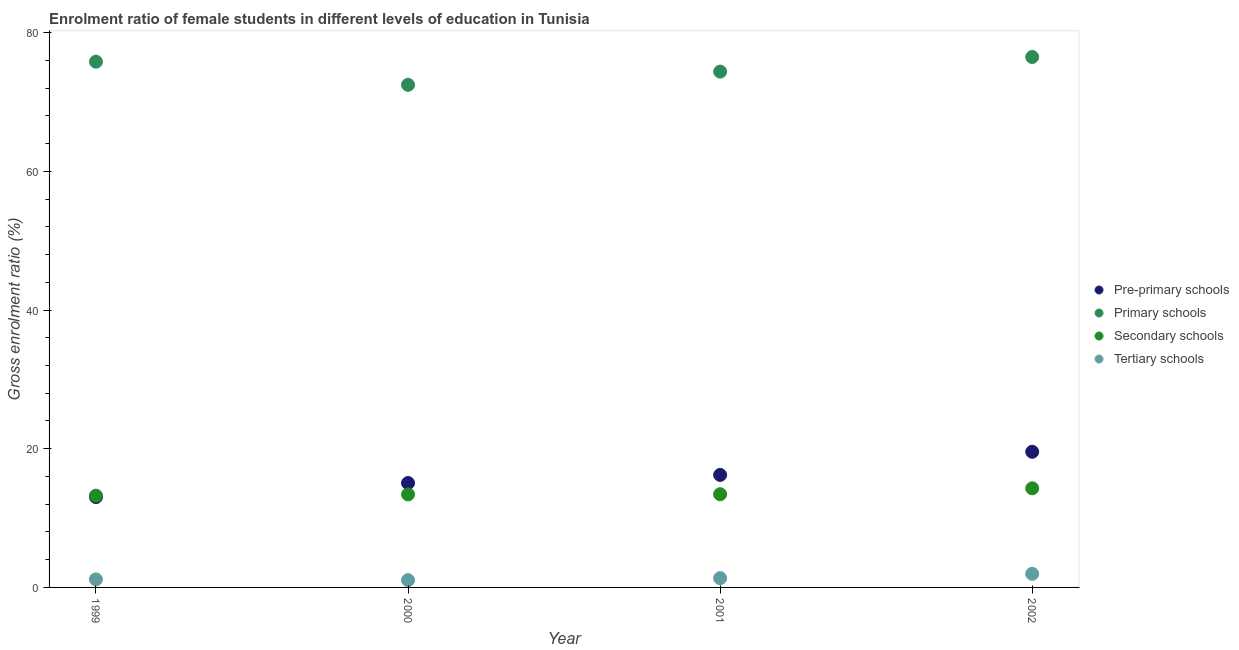What is the gross enrolment ratio(male) in primary schools in 2002?
Make the answer very short. 76.49. Across all years, what is the maximum gross enrolment ratio(male) in tertiary schools?
Keep it short and to the point. 1.96. Across all years, what is the minimum gross enrolment ratio(male) in primary schools?
Offer a terse response. 72.48. In which year was the gross enrolment ratio(male) in primary schools maximum?
Make the answer very short. 2002. What is the total gross enrolment ratio(male) in tertiary schools in the graph?
Provide a short and direct response. 5.51. What is the difference between the gross enrolment ratio(male) in primary schools in 1999 and that in 2001?
Your response must be concise. 1.43. What is the difference between the gross enrolment ratio(male) in secondary schools in 2001 and the gross enrolment ratio(male) in primary schools in 2002?
Give a very brief answer. -63.05. What is the average gross enrolment ratio(male) in pre-primary schools per year?
Your answer should be very brief. 15.97. In the year 1999, what is the difference between the gross enrolment ratio(male) in primary schools and gross enrolment ratio(male) in pre-primary schools?
Your answer should be compact. 62.79. In how many years, is the gross enrolment ratio(male) in tertiary schools greater than 8 %?
Make the answer very short. 0. What is the ratio of the gross enrolment ratio(male) in tertiary schools in 2000 to that in 2001?
Offer a terse response. 0.78. Is the gross enrolment ratio(male) in pre-primary schools in 1999 less than that in 2002?
Your answer should be very brief. Yes. Is the difference between the gross enrolment ratio(male) in pre-primary schools in 1999 and 2002 greater than the difference between the gross enrolment ratio(male) in primary schools in 1999 and 2002?
Make the answer very short. No. What is the difference between the highest and the second highest gross enrolment ratio(male) in tertiary schools?
Offer a terse response. 0.62. What is the difference between the highest and the lowest gross enrolment ratio(male) in primary schools?
Your answer should be compact. 4.02. In how many years, is the gross enrolment ratio(male) in pre-primary schools greater than the average gross enrolment ratio(male) in pre-primary schools taken over all years?
Your response must be concise. 2. Is it the case that in every year, the sum of the gross enrolment ratio(male) in tertiary schools and gross enrolment ratio(male) in primary schools is greater than the sum of gross enrolment ratio(male) in secondary schools and gross enrolment ratio(male) in pre-primary schools?
Ensure brevity in your answer.  No. Is it the case that in every year, the sum of the gross enrolment ratio(male) in pre-primary schools and gross enrolment ratio(male) in primary schools is greater than the gross enrolment ratio(male) in secondary schools?
Offer a very short reply. Yes. How many years are there in the graph?
Your answer should be compact. 4. Are the values on the major ticks of Y-axis written in scientific E-notation?
Offer a terse response. No. Does the graph contain grids?
Your answer should be very brief. No. Where does the legend appear in the graph?
Your answer should be compact. Center right. How are the legend labels stacked?
Keep it short and to the point. Vertical. What is the title of the graph?
Your response must be concise. Enrolment ratio of female students in different levels of education in Tunisia. What is the Gross enrolment ratio (%) in Pre-primary schools in 1999?
Offer a very short reply. 13.03. What is the Gross enrolment ratio (%) of Primary schools in 1999?
Keep it short and to the point. 75.81. What is the Gross enrolment ratio (%) of Secondary schools in 1999?
Offer a terse response. 13.23. What is the Gross enrolment ratio (%) of Tertiary schools in 1999?
Offer a terse response. 1.16. What is the Gross enrolment ratio (%) of Pre-primary schools in 2000?
Make the answer very short. 15.05. What is the Gross enrolment ratio (%) in Primary schools in 2000?
Give a very brief answer. 72.48. What is the Gross enrolment ratio (%) of Secondary schools in 2000?
Make the answer very short. 13.41. What is the Gross enrolment ratio (%) in Tertiary schools in 2000?
Offer a terse response. 1.05. What is the Gross enrolment ratio (%) of Pre-primary schools in 2001?
Ensure brevity in your answer.  16.22. What is the Gross enrolment ratio (%) of Primary schools in 2001?
Offer a very short reply. 74.38. What is the Gross enrolment ratio (%) of Secondary schools in 2001?
Provide a succinct answer. 13.44. What is the Gross enrolment ratio (%) of Tertiary schools in 2001?
Ensure brevity in your answer.  1.34. What is the Gross enrolment ratio (%) in Pre-primary schools in 2002?
Offer a terse response. 19.56. What is the Gross enrolment ratio (%) of Primary schools in 2002?
Make the answer very short. 76.49. What is the Gross enrolment ratio (%) of Secondary schools in 2002?
Make the answer very short. 14.29. What is the Gross enrolment ratio (%) in Tertiary schools in 2002?
Your answer should be very brief. 1.96. Across all years, what is the maximum Gross enrolment ratio (%) in Pre-primary schools?
Your answer should be compact. 19.56. Across all years, what is the maximum Gross enrolment ratio (%) of Primary schools?
Offer a very short reply. 76.49. Across all years, what is the maximum Gross enrolment ratio (%) of Secondary schools?
Provide a short and direct response. 14.29. Across all years, what is the maximum Gross enrolment ratio (%) in Tertiary schools?
Provide a short and direct response. 1.96. Across all years, what is the minimum Gross enrolment ratio (%) in Pre-primary schools?
Your response must be concise. 13.03. Across all years, what is the minimum Gross enrolment ratio (%) of Primary schools?
Provide a succinct answer. 72.48. Across all years, what is the minimum Gross enrolment ratio (%) in Secondary schools?
Keep it short and to the point. 13.23. Across all years, what is the minimum Gross enrolment ratio (%) in Tertiary schools?
Your answer should be very brief. 1.05. What is the total Gross enrolment ratio (%) in Pre-primary schools in the graph?
Your answer should be very brief. 63.87. What is the total Gross enrolment ratio (%) in Primary schools in the graph?
Provide a short and direct response. 299.17. What is the total Gross enrolment ratio (%) in Secondary schools in the graph?
Your response must be concise. 54.38. What is the total Gross enrolment ratio (%) in Tertiary schools in the graph?
Make the answer very short. 5.51. What is the difference between the Gross enrolment ratio (%) of Pre-primary schools in 1999 and that in 2000?
Ensure brevity in your answer.  -2.03. What is the difference between the Gross enrolment ratio (%) of Primary schools in 1999 and that in 2000?
Offer a terse response. 3.34. What is the difference between the Gross enrolment ratio (%) of Secondary schools in 1999 and that in 2000?
Provide a short and direct response. -0.18. What is the difference between the Gross enrolment ratio (%) of Tertiary schools in 1999 and that in 2000?
Provide a short and direct response. 0.11. What is the difference between the Gross enrolment ratio (%) of Pre-primary schools in 1999 and that in 2001?
Provide a short and direct response. -3.19. What is the difference between the Gross enrolment ratio (%) in Primary schools in 1999 and that in 2001?
Your answer should be compact. 1.43. What is the difference between the Gross enrolment ratio (%) of Secondary schools in 1999 and that in 2001?
Keep it short and to the point. -0.2. What is the difference between the Gross enrolment ratio (%) of Tertiary schools in 1999 and that in 2001?
Provide a succinct answer. -0.18. What is the difference between the Gross enrolment ratio (%) in Pre-primary schools in 1999 and that in 2002?
Ensure brevity in your answer.  -6.53. What is the difference between the Gross enrolment ratio (%) in Primary schools in 1999 and that in 2002?
Keep it short and to the point. -0.68. What is the difference between the Gross enrolment ratio (%) in Secondary schools in 1999 and that in 2002?
Give a very brief answer. -1.06. What is the difference between the Gross enrolment ratio (%) in Tertiary schools in 1999 and that in 2002?
Offer a very short reply. -0.8. What is the difference between the Gross enrolment ratio (%) in Pre-primary schools in 2000 and that in 2001?
Your answer should be compact. -1.17. What is the difference between the Gross enrolment ratio (%) in Primary schools in 2000 and that in 2001?
Your response must be concise. -1.91. What is the difference between the Gross enrolment ratio (%) in Secondary schools in 2000 and that in 2001?
Keep it short and to the point. -0.03. What is the difference between the Gross enrolment ratio (%) of Tertiary schools in 2000 and that in 2001?
Your response must be concise. -0.29. What is the difference between the Gross enrolment ratio (%) in Pre-primary schools in 2000 and that in 2002?
Make the answer very short. -4.51. What is the difference between the Gross enrolment ratio (%) in Primary schools in 2000 and that in 2002?
Provide a short and direct response. -4.02. What is the difference between the Gross enrolment ratio (%) in Secondary schools in 2000 and that in 2002?
Your answer should be compact. -0.88. What is the difference between the Gross enrolment ratio (%) of Tertiary schools in 2000 and that in 2002?
Make the answer very short. -0.91. What is the difference between the Gross enrolment ratio (%) in Pre-primary schools in 2001 and that in 2002?
Your answer should be compact. -3.34. What is the difference between the Gross enrolment ratio (%) in Primary schools in 2001 and that in 2002?
Provide a short and direct response. -2.11. What is the difference between the Gross enrolment ratio (%) of Secondary schools in 2001 and that in 2002?
Your response must be concise. -0.85. What is the difference between the Gross enrolment ratio (%) in Tertiary schools in 2001 and that in 2002?
Keep it short and to the point. -0.62. What is the difference between the Gross enrolment ratio (%) of Pre-primary schools in 1999 and the Gross enrolment ratio (%) of Primary schools in 2000?
Offer a terse response. -59.45. What is the difference between the Gross enrolment ratio (%) of Pre-primary schools in 1999 and the Gross enrolment ratio (%) of Secondary schools in 2000?
Offer a very short reply. -0.38. What is the difference between the Gross enrolment ratio (%) of Pre-primary schools in 1999 and the Gross enrolment ratio (%) of Tertiary schools in 2000?
Offer a very short reply. 11.98. What is the difference between the Gross enrolment ratio (%) in Primary schools in 1999 and the Gross enrolment ratio (%) in Secondary schools in 2000?
Offer a very short reply. 62.4. What is the difference between the Gross enrolment ratio (%) of Primary schools in 1999 and the Gross enrolment ratio (%) of Tertiary schools in 2000?
Provide a short and direct response. 74.77. What is the difference between the Gross enrolment ratio (%) of Secondary schools in 1999 and the Gross enrolment ratio (%) of Tertiary schools in 2000?
Give a very brief answer. 12.19. What is the difference between the Gross enrolment ratio (%) of Pre-primary schools in 1999 and the Gross enrolment ratio (%) of Primary schools in 2001?
Your answer should be very brief. -61.36. What is the difference between the Gross enrolment ratio (%) of Pre-primary schools in 1999 and the Gross enrolment ratio (%) of Secondary schools in 2001?
Your response must be concise. -0.41. What is the difference between the Gross enrolment ratio (%) in Pre-primary schools in 1999 and the Gross enrolment ratio (%) in Tertiary schools in 2001?
Offer a terse response. 11.69. What is the difference between the Gross enrolment ratio (%) of Primary schools in 1999 and the Gross enrolment ratio (%) of Secondary schools in 2001?
Your response must be concise. 62.38. What is the difference between the Gross enrolment ratio (%) of Primary schools in 1999 and the Gross enrolment ratio (%) of Tertiary schools in 2001?
Ensure brevity in your answer.  74.47. What is the difference between the Gross enrolment ratio (%) of Secondary schools in 1999 and the Gross enrolment ratio (%) of Tertiary schools in 2001?
Provide a short and direct response. 11.89. What is the difference between the Gross enrolment ratio (%) in Pre-primary schools in 1999 and the Gross enrolment ratio (%) in Primary schools in 2002?
Keep it short and to the point. -63.46. What is the difference between the Gross enrolment ratio (%) in Pre-primary schools in 1999 and the Gross enrolment ratio (%) in Secondary schools in 2002?
Offer a very short reply. -1.26. What is the difference between the Gross enrolment ratio (%) of Pre-primary schools in 1999 and the Gross enrolment ratio (%) of Tertiary schools in 2002?
Offer a very short reply. 11.07. What is the difference between the Gross enrolment ratio (%) in Primary schools in 1999 and the Gross enrolment ratio (%) in Secondary schools in 2002?
Your response must be concise. 61.52. What is the difference between the Gross enrolment ratio (%) in Primary schools in 1999 and the Gross enrolment ratio (%) in Tertiary schools in 2002?
Provide a short and direct response. 73.86. What is the difference between the Gross enrolment ratio (%) of Secondary schools in 1999 and the Gross enrolment ratio (%) of Tertiary schools in 2002?
Give a very brief answer. 11.27. What is the difference between the Gross enrolment ratio (%) in Pre-primary schools in 2000 and the Gross enrolment ratio (%) in Primary schools in 2001?
Make the answer very short. -59.33. What is the difference between the Gross enrolment ratio (%) in Pre-primary schools in 2000 and the Gross enrolment ratio (%) in Secondary schools in 2001?
Your answer should be very brief. 1.62. What is the difference between the Gross enrolment ratio (%) in Pre-primary schools in 2000 and the Gross enrolment ratio (%) in Tertiary schools in 2001?
Your response must be concise. 13.71. What is the difference between the Gross enrolment ratio (%) in Primary schools in 2000 and the Gross enrolment ratio (%) in Secondary schools in 2001?
Provide a succinct answer. 59.04. What is the difference between the Gross enrolment ratio (%) in Primary schools in 2000 and the Gross enrolment ratio (%) in Tertiary schools in 2001?
Provide a short and direct response. 71.14. What is the difference between the Gross enrolment ratio (%) of Secondary schools in 2000 and the Gross enrolment ratio (%) of Tertiary schools in 2001?
Offer a terse response. 12.07. What is the difference between the Gross enrolment ratio (%) of Pre-primary schools in 2000 and the Gross enrolment ratio (%) of Primary schools in 2002?
Your answer should be very brief. -61.44. What is the difference between the Gross enrolment ratio (%) in Pre-primary schools in 2000 and the Gross enrolment ratio (%) in Secondary schools in 2002?
Provide a short and direct response. 0.76. What is the difference between the Gross enrolment ratio (%) in Pre-primary schools in 2000 and the Gross enrolment ratio (%) in Tertiary schools in 2002?
Offer a very short reply. 13.1. What is the difference between the Gross enrolment ratio (%) of Primary schools in 2000 and the Gross enrolment ratio (%) of Secondary schools in 2002?
Your answer should be very brief. 58.19. What is the difference between the Gross enrolment ratio (%) in Primary schools in 2000 and the Gross enrolment ratio (%) in Tertiary schools in 2002?
Offer a terse response. 70.52. What is the difference between the Gross enrolment ratio (%) of Secondary schools in 2000 and the Gross enrolment ratio (%) of Tertiary schools in 2002?
Provide a succinct answer. 11.45. What is the difference between the Gross enrolment ratio (%) of Pre-primary schools in 2001 and the Gross enrolment ratio (%) of Primary schools in 2002?
Provide a short and direct response. -60.27. What is the difference between the Gross enrolment ratio (%) of Pre-primary schools in 2001 and the Gross enrolment ratio (%) of Secondary schools in 2002?
Your answer should be very brief. 1.93. What is the difference between the Gross enrolment ratio (%) of Pre-primary schools in 2001 and the Gross enrolment ratio (%) of Tertiary schools in 2002?
Your answer should be compact. 14.26. What is the difference between the Gross enrolment ratio (%) of Primary schools in 2001 and the Gross enrolment ratio (%) of Secondary schools in 2002?
Offer a very short reply. 60.09. What is the difference between the Gross enrolment ratio (%) of Primary schools in 2001 and the Gross enrolment ratio (%) of Tertiary schools in 2002?
Your answer should be very brief. 72.43. What is the difference between the Gross enrolment ratio (%) in Secondary schools in 2001 and the Gross enrolment ratio (%) in Tertiary schools in 2002?
Offer a terse response. 11.48. What is the average Gross enrolment ratio (%) of Pre-primary schools per year?
Provide a succinct answer. 15.97. What is the average Gross enrolment ratio (%) of Primary schools per year?
Your answer should be very brief. 74.79. What is the average Gross enrolment ratio (%) of Secondary schools per year?
Give a very brief answer. 13.59. What is the average Gross enrolment ratio (%) of Tertiary schools per year?
Your answer should be compact. 1.38. In the year 1999, what is the difference between the Gross enrolment ratio (%) of Pre-primary schools and Gross enrolment ratio (%) of Primary schools?
Give a very brief answer. -62.79. In the year 1999, what is the difference between the Gross enrolment ratio (%) of Pre-primary schools and Gross enrolment ratio (%) of Secondary schools?
Your response must be concise. -0.2. In the year 1999, what is the difference between the Gross enrolment ratio (%) of Pre-primary schools and Gross enrolment ratio (%) of Tertiary schools?
Your answer should be very brief. 11.87. In the year 1999, what is the difference between the Gross enrolment ratio (%) of Primary schools and Gross enrolment ratio (%) of Secondary schools?
Provide a succinct answer. 62.58. In the year 1999, what is the difference between the Gross enrolment ratio (%) of Primary schools and Gross enrolment ratio (%) of Tertiary schools?
Offer a terse response. 74.65. In the year 1999, what is the difference between the Gross enrolment ratio (%) of Secondary schools and Gross enrolment ratio (%) of Tertiary schools?
Offer a terse response. 12.07. In the year 2000, what is the difference between the Gross enrolment ratio (%) in Pre-primary schools and Gross enrolment ratio (%) in Primary schools?
Give a very brief answer. -57.42. In the year 2000, what is the difference between the Gross enrolment ratio (%) of Pre-primary schools and Gross enrolment ratio (%) of Secondary schools?
Offer a terse response. 1.64. In the year 2000, what is the difference between the Gross enrolment ratio (%) in Pre-primary schools and Gross enrolment ratio (%) in Tertiary schools?
Offer a very short reply. 14.01. In the year 2000, what is the difference between the Gross enrolment ratio (%) of Primary schools and Gross enrolment ratio (%) of Secondary schools?
Offer a very short reply. 59.06. In the year 2000, what is the difference between the Gross enrolment ratio (%) of Primary schools and Gross enrolment ratio (%) of Tertiary schools?
Ensure brevity in your answer.  71.43. In the year 2000, what is the difference between the Gross enrolment ratio (%) in Secondary schools and Gross enrolment ratio (%) in Tertiary schools?
Ensure brevity in your answer.  12.37. In the year 2001, what is the difference between the Gross enrolment ratio (%) in Pre-primary schools and Gross enrolment ratio (%) in Primary schools?
Offer a very short reply. -58.16. In the year 2001, what is the difference between the Gross enrolment ratio (%) of Pre-primary schools and Gross enrolment ratio (%) of Secondary schools?
Make the answer very short. 2.78. In the year 2001, what is the difference between the Gross enrolment ratio (%) of Pre-primary schools and Gross enrolment ratio (%) of Tertiary schools?
Offer a terse response. 14.88. In the year 2001, what is the difference between the Gross enrolment ratio (%) in Primary schools and Gross enrolment ratio (%) in Secondary schools?
Provide a short and direct response. 60.95. In the year 2001, what is the difference between the Gross enrolment ratio (%) of Primary schools and Gross enrolment ratio (%) of Tertiary schools?
Your answer should be compact. 73.04. In the year 2001, what is the difference between the Gross enrolment ratio (%) of Secondary schools and Gross enrolment ratio (%) of Tertiary schools?
Your answer should be very brief. 12.1. In the year 2002, what is the difference between the Gross enrolment ratio (%) in Pre-primary schools and Gross enrolment ratio (%) in Primary schools?
Offer a very short reply. -56.93. In the year 2002, what is the difference between the Gross enrolment ratio (%) of Pre-primary schools and Gross enrolment ratio (%) of Secondary schools?
Give a very brief answer. 5.27. In the year 2002, what is the difference between the Gross enrolment ratio (%) of Pre-primary schools and Gross enrolment ratio (%) of Tertiary schools?
Your answer should be compact. 17.6. In the year 2002, what is the difference between the Gross enrolment ratio (%) of Primary schools and Gross enrolment ratio (%) of Secondary schools?
Provide a succinct answer. 62.2. In the year 2002, what is the difference between the Gross enrolment ratio (%) of Primary schools and Gross enrolment ratio (%) of Tertiary schools?
Your answer should be very brief. 74.53. In the year 2002, what is the difference between the Gross enrolment ratio (%) of Secondary schools and Gross enrolment ratio (%) of Tertiary schools?
Provide a succinct answer. 12.33. What is the ratio of the Gross enrolment ratio (%) in Pre-primary schools in 1999 to that in 2000?
Your answer should be compact. 0.87. What is the ratio of the Gross enrolment ratio (%) in Primary schools in 1999 to that in 2000?
Offer a terse response. 1.05. What is the ratio of the Gross enrolment ratio (%) of Secondary schools in 1999 to that in 2000?
Offer a terse response. 0.99. What is the ratio of the Gross enrolment ratio (%) of Tertiary schools in 1999 to that in 2000?
Give a very brief answer. 1.11. What is the ratio of the Gross enrolment ratio (%) of Pre-primary schools in 1999 to that in 2001?
Provide a succinct answer. 0.8. What is the ratio of the Gross enrolment ratio (%) of Primary schools in 1999 to that in 2001?
Keep it short and to the point. 1.02. What is the ratio of the Gross enrolment ratio (%) in Tertiary schools in 1999 to that in 2001?
Keep it short and to the point. 0.87. What is the ratio of the Gross enrolment ratio (%) of Pre-primary schools in 1999 to that in 2002?
Offer a very short reply. 0.67. What is the ratio of the Gross enrolment ratio (%) of Secondary schools in 1999 to that in 2002?
Keep it short and to the point. 0.93. What is the ratio of the Gross enrolment ratio (%) of Tertiary schools in 1999 to that in 2002?
Ensure brevity in your answer.  0.59. What is the ratio of the Gross enrolment ratio (%) of Pre-primary schools in 2000 to that in 2001?
Ensure brevity in your answer.  0.93. What is the ratio of the Gross enrolment ratio (%) in Primary schools in 2000 to that in 2001?
Provide a short and direct response. 0.97. What is the ratio of the Gross enrolment ratio (%) in Tertiary schools in 2000 to that in 2001?
Offer a very short reply. 0.78. What is the ratio of the Gross enrolment ratio (%) in Pre-primary schools in 2000 to that in 2002?
Ensure brevity in your answer.  0.77. What is the ratio of the Gross enrolment ratio (%) in Primary schools in 2000 to that in 2002?
Provide a succinct answer. 0.95. What is the ratio of the Gross enrolment ratio (%) of Secondary schools in 2000 to that in 2002?
Your answer should be very brief. 0.94. What is the ratio of the Gross enrolment ratio (%) of Tertiary schools in 2000 to that in 2002?
Keep it short and to the point. 0.53. What is the ratio of the Gross enrolment ratio (%) of Pre-primary schools in 2001 to that in 2002?
Provide a succinct answer. 0.83. What is the ratio of the Gross enrolment ratio (%) of Primary schools in 2001 to that in 2002?
Offer a very short reply. 0.97. What is the ratio of the Gross enrolment ratio (%) in Secondary schools in 2001 to that in 2002?
Offer a very short reply. 0.94. What is the ratio of the Gross enrolment ratio (%) of Tertiary schools in 2001 to that in 2002?
Keep it short and to the point. 0.68. What is the difference between the highest and the second highest Gross enrolment ratio (%) of Pre-primary schools?
Provide a succinct answer. 3.34. What is the difference between the highest and the second highest Gross enrolment ratio (%) of Primary schools?
Offer a terse response. 0.68. What is the difference between the highest and the second highest Gross enrolment ratio (%) in Secondary schools?
Ensure brevity in your answer.  0.85. What is the difference between the highest and the second highest Gross enrolment ratio (%) in Tertiary schools?
Provide a succinct answer. 0.62. What is the difference between the highest and the lowest Gross enrolment ratio (%) in Pre-primary schools?
Your answer should be very brief. 6.53. What is the difference between the highest and the lowest Gross enrolment ratio (%) in Primary schools?
Your answer should be compact. 4.02. What is the difference between the highest and the lowest Gross enrolment ratio (%) of Secondary schools?
Provide a succinct answer. 1.06. What is the difference between the highest and the lowest Gross enrolment ratio (%) in Tertiary schools?
Provide a short and direct response. 0.91. 